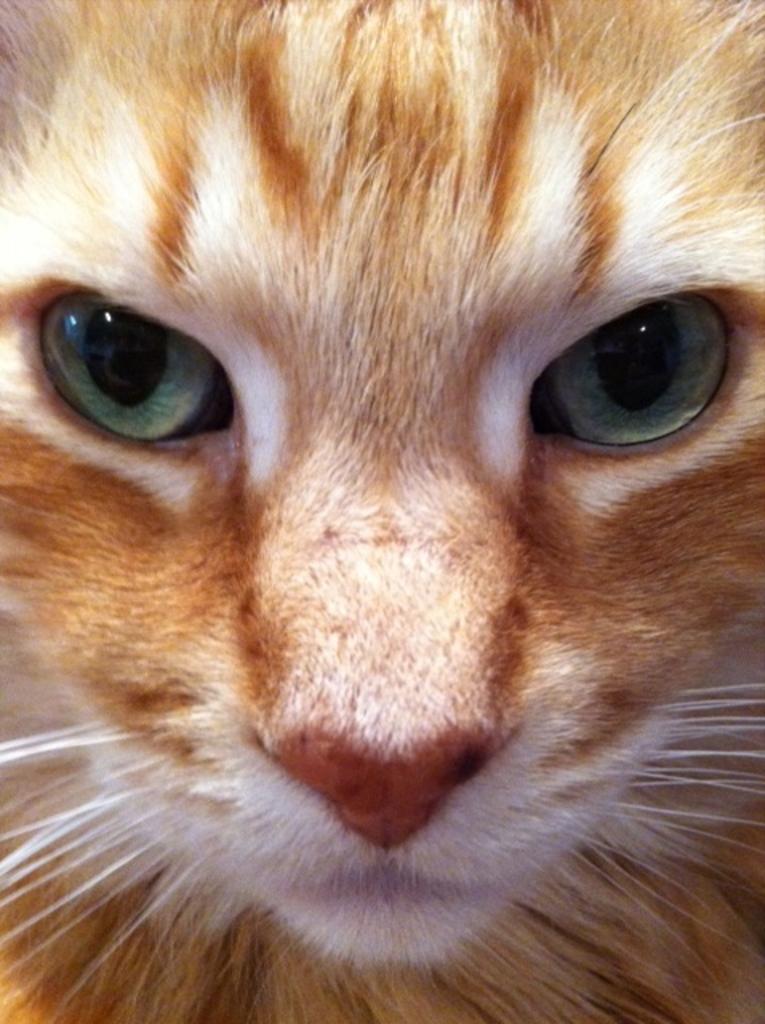In one or two sentences, can you explain what this image depicts? In this image there is a cat. 